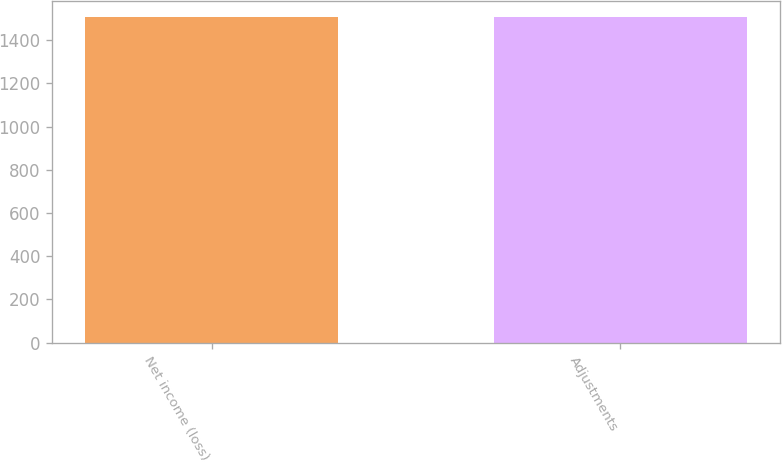<chart> <loc_0><loc_0><loc_500><loc_500><bar_chart><fcel>Net income (loss)<fcel>Adjustments<nl><fcel>1506<fcel>1506.1<nl></chart> 